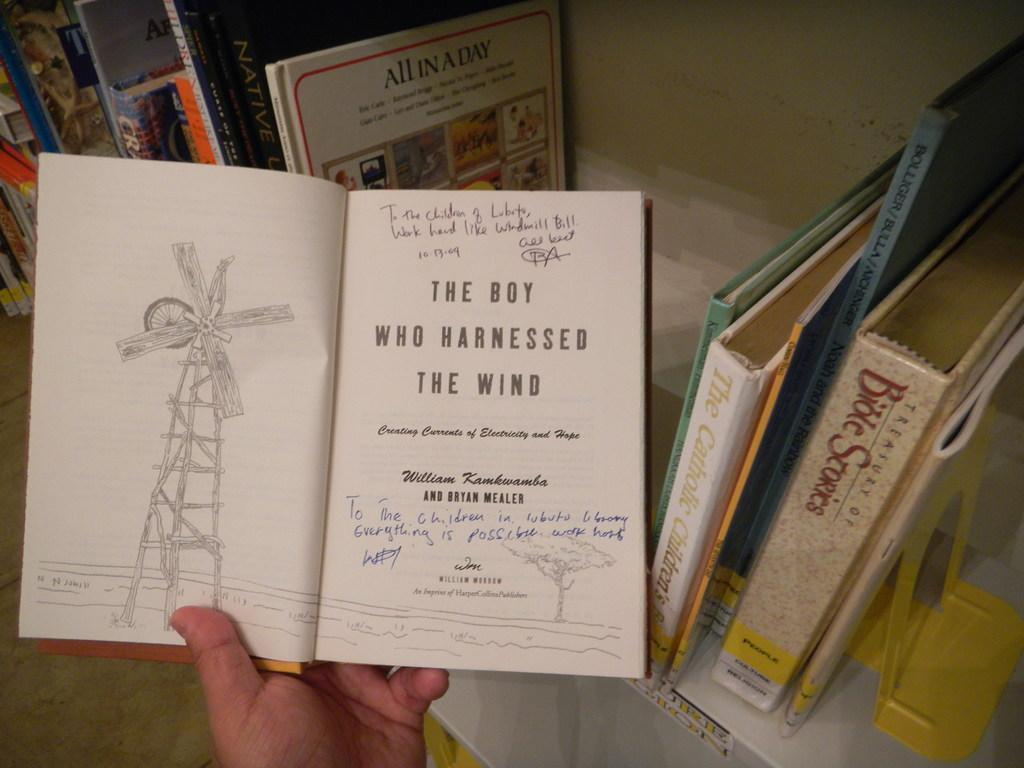What can be seen on the bookshelf in the image? There is a bookshelf with books in the image. What is the person's hand doing in the image? A person's hand is holding a book in the image. What part of the room is visible at the bottom of the image? There is floor visible at the bottom of the image. What type of rice can be seen on the bookshelf in the image? There is no rice present in the image. 